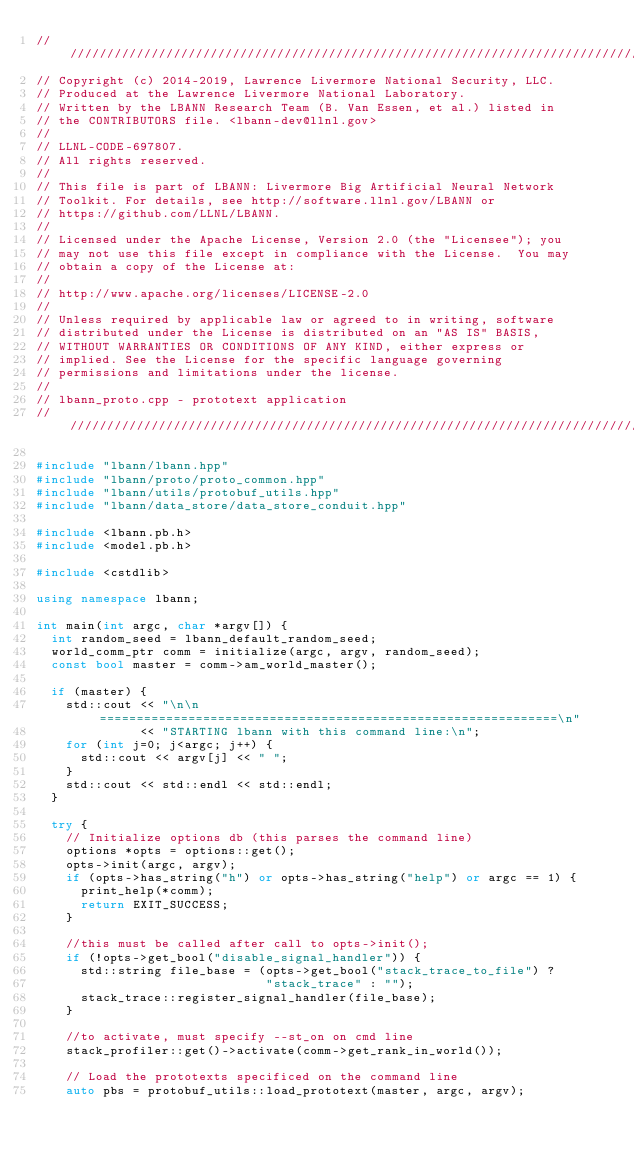<code> <loc_0><loc_0><loc_500><loc_500><_C++_>////////////////////////////////////////////////////////////////////////////////
// Copyright (c) 2014-2019, Lawrence Livermore National Security, LLC.
// Produced at the Lawrence Livermore National Laboratory.
// Written by the LBANN Research Team (B. Van Essen, et al.) listed in
// the CONTRIBUTORS file. <lbann-dev@llnl.gov>
//
// LLNL-CODE-697807.
// All rights reserved.
//
// This file is part of LBANN: Livermore Big Artificial Neural Network
// Toolkit. For details, see http://software.llnl.gov/LBANN or
// https://github.com/LLNL/LBANN.
//
// Licensed under the Apache License, Version 2.0 (the "Licensee"); you
// may not use this file except in compliance with the License.  You may
// obtain a copy of the License at:
//
// http://www.apache.org/licenses/LICENSE-2.0
//
// Unless required by applicable law or agreed to in writing, software
// distributed under the License is distributed on an "AS IS" BASIS,
// WITHOUT WARRANTIES OR CONDITIONS OF ANY KIND, either express or
// implied. See the License for the specific language governing
// permissions and limitations under the license.
//
// lbann_proto.cpp - prototext application
////////////////////////////////////////////////////////////////////////////////

#include "lbann/lbann.hpp"
#include "lbann/proto/proto_common.hpp"
#include "lbann/utils/protobuf_utils.hpp"
#include "lbann/data_store/data_store_conduit.hpp"

#include <lbann.pb.h>
#include <model.pb.h>

#include <cstdlib>

using namespace lbann;

int main(int argc, char *argv[]) {
  int random_seed = lbann_default_random_seed;
  world_comm_ptr comm = initialize(argc, argv, random_seed);
  const bool master = comm->am_world_master();

  if (master) {
    std::cout << "\n\n==============================================================\n"
              << "STARTING lbann with this command line:\n";
    for (int j=0; j<argc; j++) {
      std::cout << argv[j] << " ";
    }
    std::cout << std::endl << std::endl;
  }

  try {
    // Initialize options db (this parses the command line)
    options *opts = options::get();
    opts->init(argc, argv);
    if (opts->has_string("h") or opts->has_string("help") or argc == 1) {
      print_help(*comm);
      return EXIT_SUCCESS;
    }

    //this must be called after call to opts->init();
    if (!opts->get_bool("disable_signal_handler")) {
      std::string file_base = (opts->get_bool("stack_trace_to_file") ?
                               "stack_trace" : "");
      stack_trace::register_signal_handler(file_base);
    }

    //to activate, must specify --st_on on cmd line
    stack_profiler::get()->activate(comm->get_rank_in_world());

    // Load the prototexts specificed on the command line
    auto pbs = protobuf_utils::load_prototext(master, argc, argv);</code> 